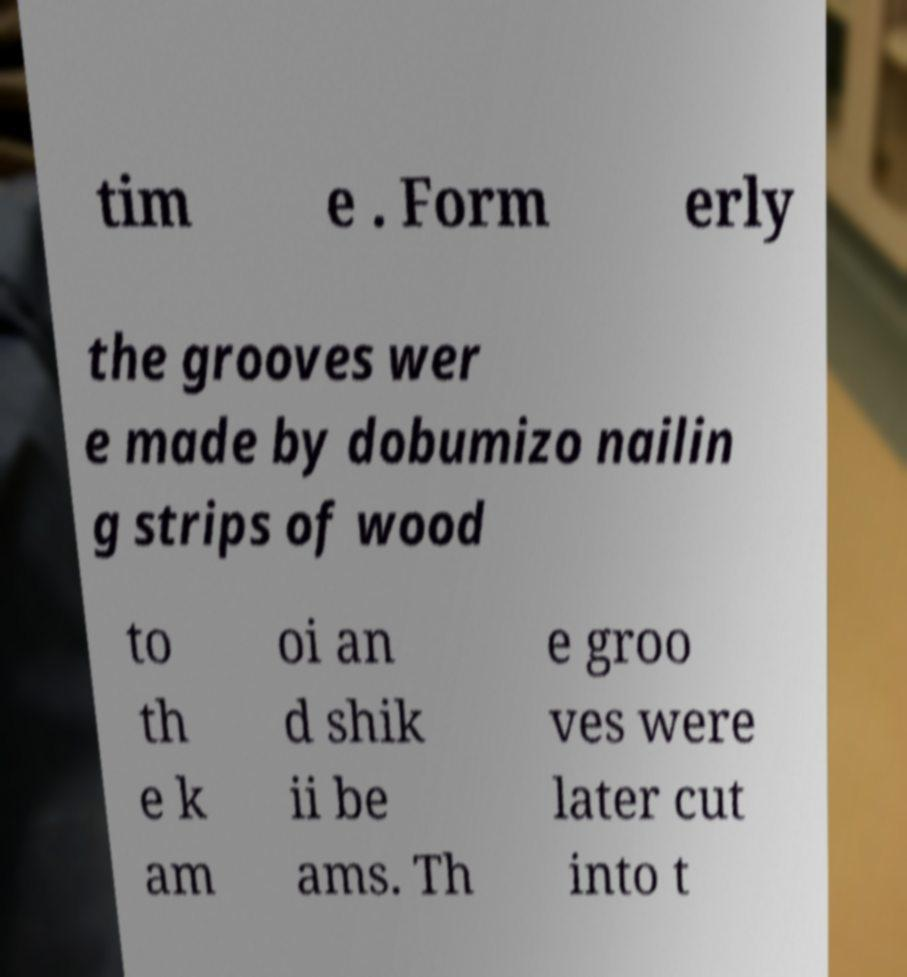There's text embedded in this image that I need extracted. Can you transcribe it verbatim? tim e . Form erly the grooves wer e made by dobumizo nailin g strips of wood to th e k am oi an d shik ii be ams. Th e groo ves were later cut into t 